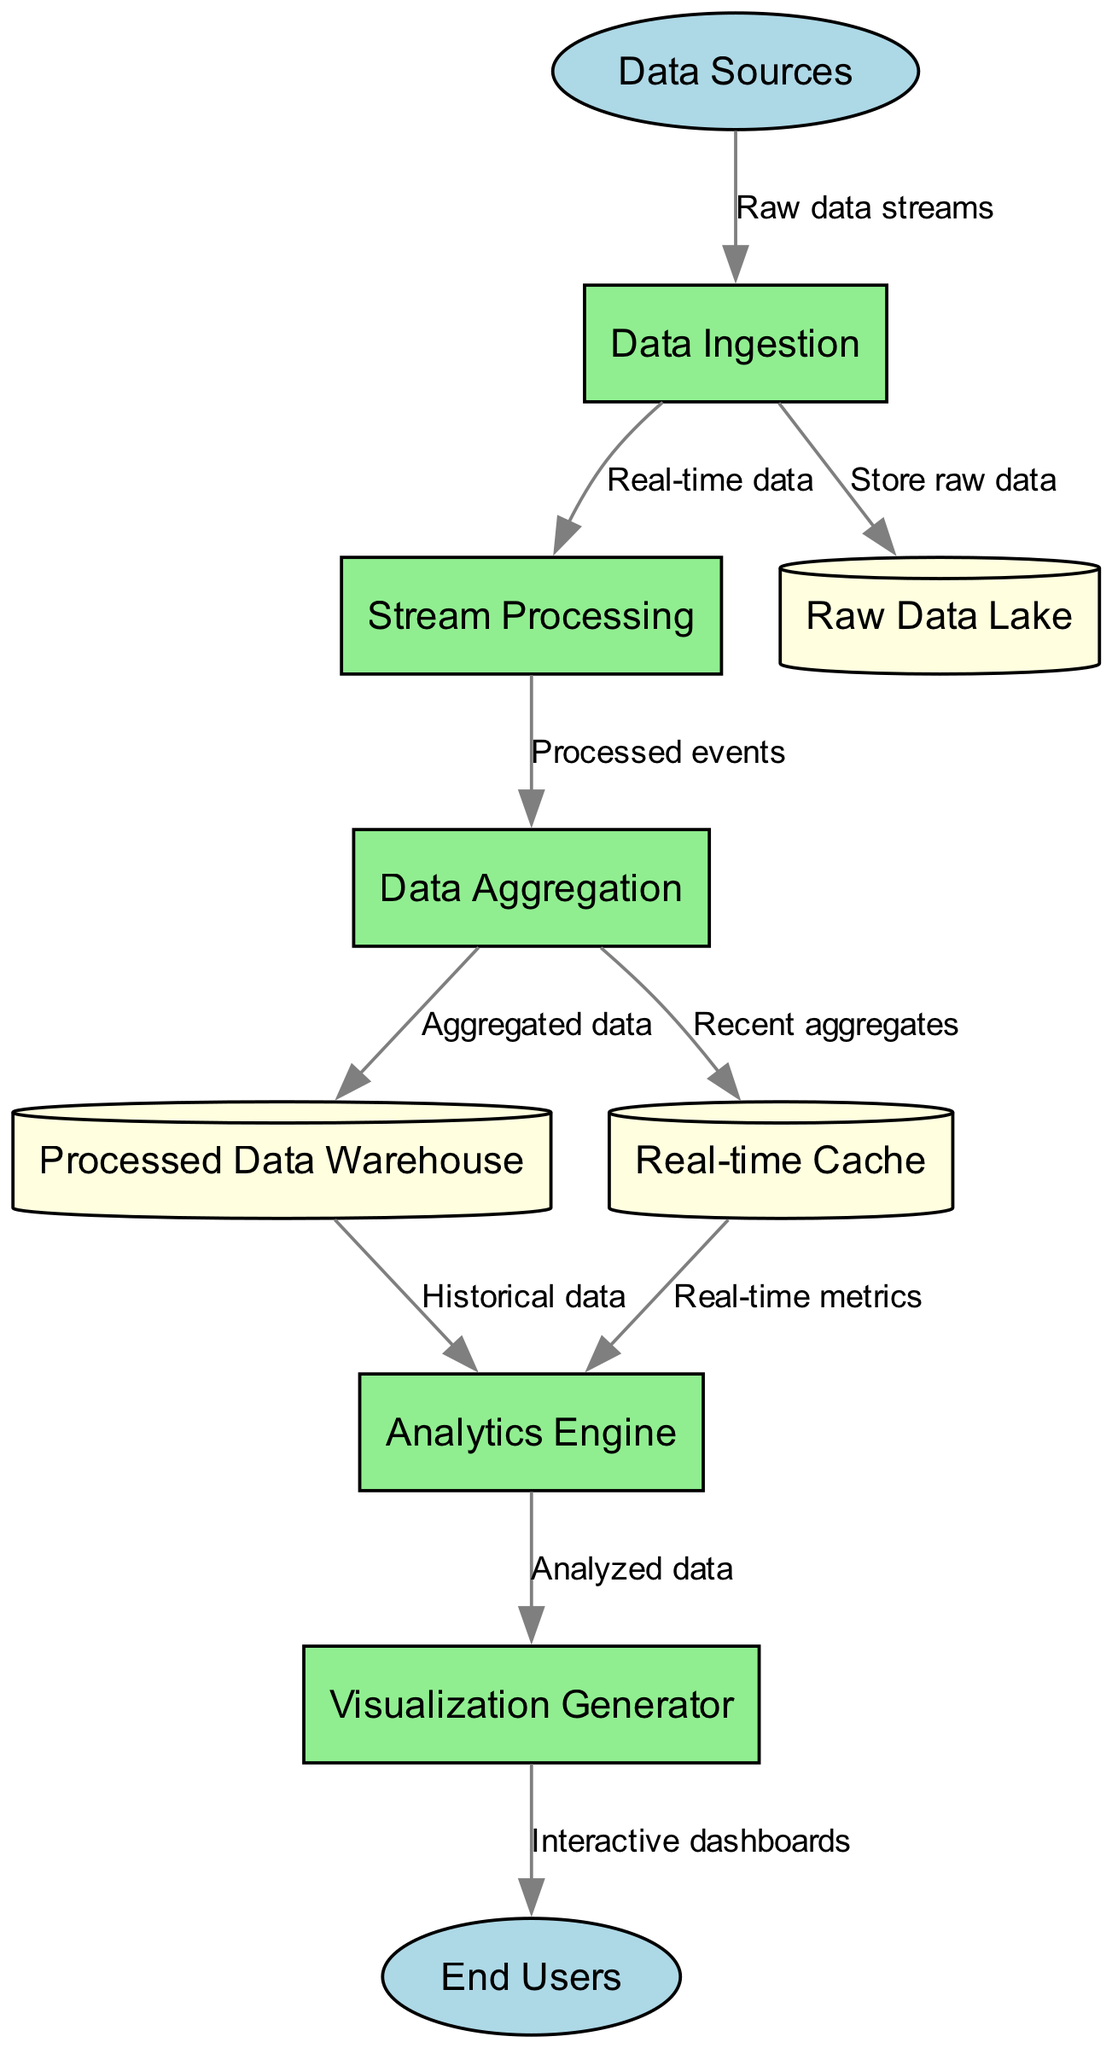What are the external entities in the diagram? The external entities identified are "Data Sources" and "End Users," as outlined in the section for external entities of the diagram.
Answer: Data Sources, End Users How many processes are there in the data flow diagram? By counting the entries in the processes section, we find five distinct processes: Data Ingestion, Stream Processing, Data Aggregation, Analytics Engine, and Visualization Generator.
Answer: 5 What does the "Data Ingestion" process send to the "Raw Data Lake"? The process "Data Ingestion" sends "Store raw data" to the "Raw Data Lake," which is explicitly labeled in the data flows section of the diagram.
Answer: Store raw data Which process receives data from both "Data Aggregation" and "Processed Data Warehouse"? The "Analytics Engine" receives input from both "Data Aggregation" and "Processed Data Warehouse" as indicated by the two separate data flows leading into it.
Answer: Analytics Engine What type of data does the "Stream Processing" process output? The "Stream Processing" process outputs "Processed events" to the "Data Aggregation" process, as detailed in the data flows of the diagram.
Answer: Processed events How many data stores are present in the diagram? The data stores listed include "Raw Data Lake," "Processed Data Warehouse," and "Real-time Cache," totaling three unique data stores in the diagram.
Answer: 3 Which process generates "Interactive dashboards"? The "Visualization Generator" is responsible for producing "Interactive dashboards" as it is the last process in the flow that sends outputs to the "End Users."
Answer: Visualization Generator What data flow connects "Real-time Cache" to "Analytics Engine"? The data flow between these nodes is labeled as "Real-time metrics," which shows the type of data that is transferred from "Real-time Cache" to "Analytics Engine."
Answer: Real-time metrics How does "Data Ingestion" contribute to "Stream Processing"? "Data Ingestion" contributes by sending "Real-time data" directly to "Stream Processing," establishing a direct flow of data for real-time processing needs.
Answer: Real-time data 